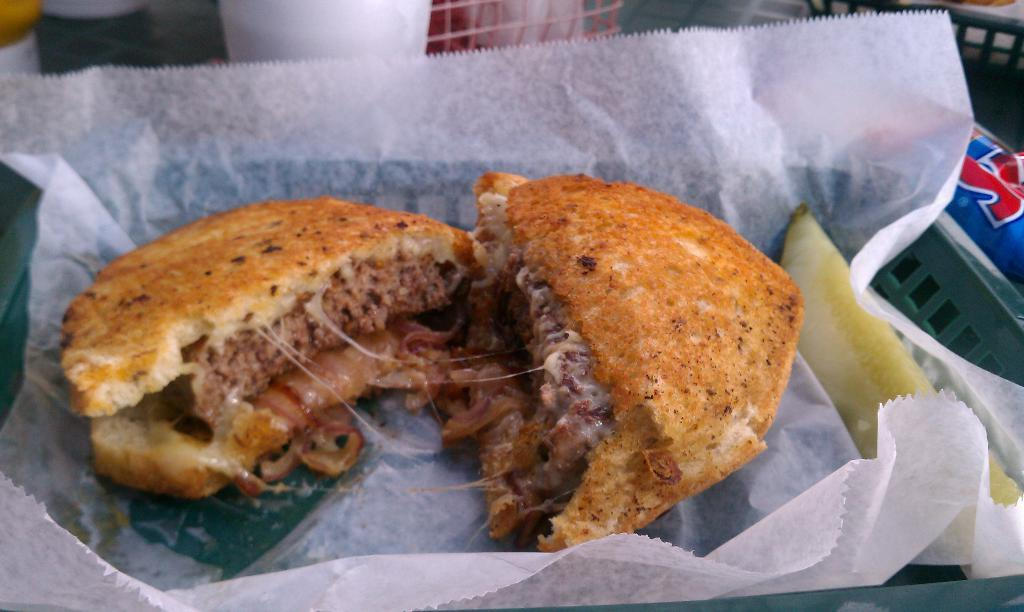What is present on the tissue in the image? There is a food item on the tissue. Can you describe the food item on the tissue? Unfortunately, the specific food item cannot be determined from the provided facts. What is the purpose of the tissue in the image? The tissue may be used to hold or serve the food item. How many goldfish are swimming in the tissue in the image? There are no goldfish present in the image; it only contains a tissue and a food item. What type of chin is visible in the image? There is no chin visible in the image. 